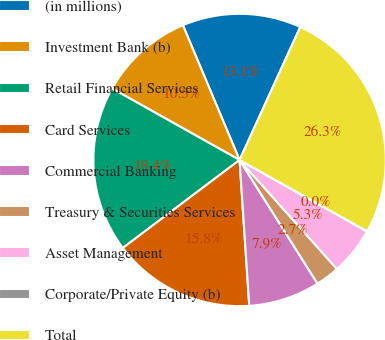Convert chart. <chart><loc_0><loc_0><loc_500><loc_500><pie_chart><fcel>(in millions)<fcel>Investment Bank (b)<fcel>Retail Financial Services<fcel>Card Services<fcel>Commercial Banking<fcel>Treasury & Securities Services<fcel>Asset Management<fcel>Corporate/Private Equity (b)<fcel>Total<nl><fcel>13.15%<fcel>10.53%<fcel>18.41%<fcel>15.78%<fcel>7.9%<fcel>2.65%<fcel>5.27%<fcel>0.02%<fcel>26.29%<nl></chart> 